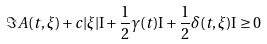<formula> <loc_0><loc_0><loc_500><loc_500>\Im A ( t , \xi ) + c | \xi | \mathrm I + \frac { 1 } { 2 } \gamma ( t ) \mathrm I + \frac { 1 } { 2 } \delta ( t , \xi ) \mathrm I \geq 0</formula> 